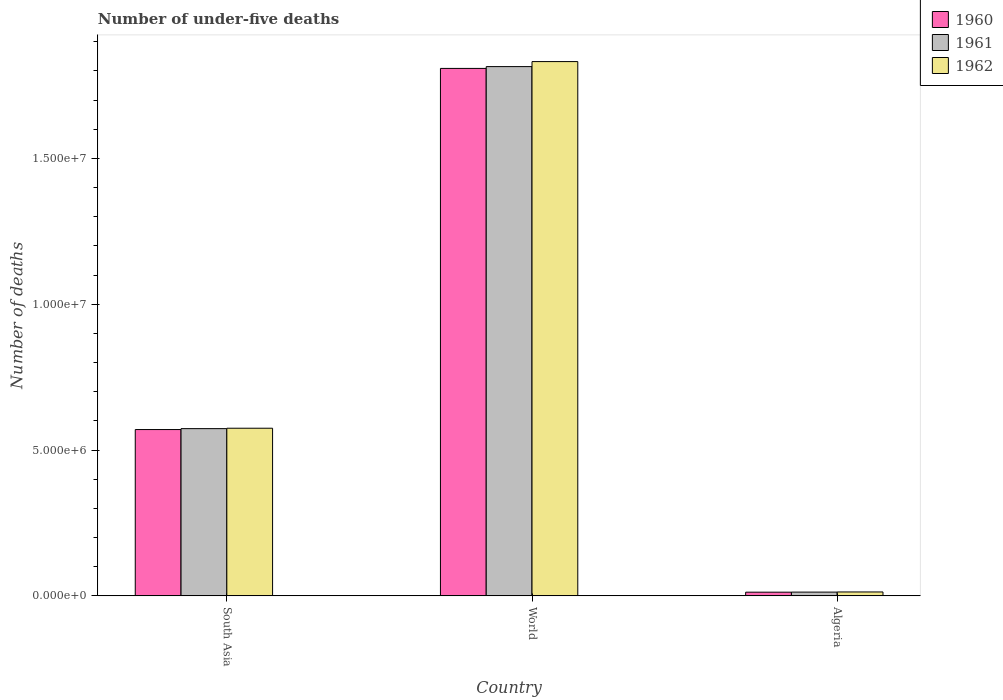How many different coloured bars are there?
Keep it short and to the point. 3. Are the number of bars per tick equal to the number of legend labels?
Provide a short and direct response. Yes. How many bars are there on the 2nd tick from the left?
Your answer should be compact. 3. How many bars are there on the 2nd tick from the right?
Ensure brevity in your answer.  3. In how many cases, is the number of bars for a given country not equal to the number of legend labels?
Provide a succinct answer. 0. What is the number of under-five deaths in 1960 in South Asia?
Ensure brevity in your answer.  5.70e+06. Across all countries, what is the maximum number of under-five deaths in 1960?
Offer a terse response. 1.81e+07. Across all countries, what is the minimum number of under-five deaths in 1962?
Offer a very short reply. 1.33e+05. In which country was the number of under-five deaths in 1960 minimum?
Give a very brief answer. Algeria. What is the total number of under-five deaths in 1960 in the graph?
Offer a terse response. 2.39e+07. What is the difference between the number of under-five deaths in 1962 in South Asia and that in World?
Provide a short and direct response. -1.26e+07. What is the difference between the number of under-five deaths in 1961 in Algeria and the number of under-five deaths in 1960 in South Asia?
Provide a succinct answer. -5.57e+06. What is the average number of under-five deaths in 1961 per country?
Give a very brief answer. 8.00e+06. What is the difference between the number of under-five deaths of/in 1962 and number of under-five deaths of/in 1960 in Algeria?
Your response must be concise. 7580. What is the ratio of the number of under-five deaths in 1961 in Algeria to that in South Asia?
Offer a very short reply. 0.02. What is the difference between the highest and the second highest number of under-five deaths in 1962?
Provide a short and direct response. -5.61e+06. What is the difference between the highest and the lowest number of under-five deaths in 1961?
Your answer should be compact. 1.80e+07. What does the 3rd bar from the left in World represents?
Ensure brevity in your answer.  1962. What does the 3rd bar from the right in World represents?
Provide a succinct answer. 1960. Is it the case that in every country, the sum of the number of under-five deaths in 1960 and number of under-five deaths in 1961 is greater than the number of under-five deaths in 1962?
Make the answer very short. Yes. How many bars are there?
Make the answer very short. 9. How many countries are there in the graph?
Your answer should be very brief. 3. Does the graph contain grids?
Your answer should be very brief. No. Where does the legend appear in the graph?
Offer a very short reply. Top right. How many legend labels are there?
Offer a very short reply. 3. What is the title of the graph?
Provide a succinct answer. Number of under-five deaths. Does "1985" appear as one of the legend labels in the graph?
Provide a short and direct response. No. What is the label or title of the Y-axis?
Keep it short and to the point. Number of deaths. What is the Number of deaths in 1960 in South Asia?
Your response must be concise. 5.70e+06. What is the Number of deaths of 1961 in South Asia?
Keep it short and to the point. 5.73e+06. What is the Number of deaths in 1962 in South Asia?
Make the answer very short. 5.75e+06. What is the Number of deaths in 1960 in World?
Your response must be concise. 1.81e+07. What is the Number of deaths of 1961 in World?
Provide a succinct answer. 1.81e+07. What is the Number of deaths in 1962 in World?
Provide a succinct answer. 1.83e+07. What is the Number of deaths of 1960 in Algeria?
Provide a short and direct response. 1.25e+05. What is the Number of deaths in 1961 in Algeria?
Ensure brevity in your answer.  1.28e+05. What is the Number of deaths in 1962 in Algeria?
Provide a short and direct response. 1.33e+05. Across all countries, what is the maximum Number of deaths in 1960?
Ensure brevity in your answer.  1.81e+07. Across all countries, what is the maximum Number of deaths of 1961?
Provide a short and direct response. 1.81e+07. Across all countries, what is the maximum Number of deaths of 1962?
Provide a short and direct response. 1.83e+07. Across all countries, what is the minimum Number of deaths in 1960?
Your answer should be compact. 1.25e+05. Across all countries, what is the minimum Number of deaths in 1961?
Provide a succinct answer. 1.28e+05. Across all countries, what is the minimum Number of deaths of 1962?
Offer a very short reply. 1.33e+05. What is the total Number of deaths in 1960 in the graph?
Provide a short and direct response. 2.39e+07. What is the total Number of deaths of 1961 in the graph?
Keep it short and to the point. 2.40e+07. What is the total Number of deaths of 1962 in the graph?
Give a very brief answer. 2.42e+07. What is the difference between the Number of deaths of 1960 in South Asia and that in World?
Your response must be concise. -1.24e+07. What is the difference between the Number of deaths of 1961 in South Asia and that in World?
Your answer should be very brief. -1.24e+07. What is the difference between the Number of deaths in 1962 in South Asia and that in World?
Provide a succinct answer. -1.26e+07. What is the difference between the Number of deaths in 1960 in South Asia and that in Algeria?
Your answer should be very brief. 5.58e+06. What is the difference between the Number of deaths in 1961 in South Asia and that in Algeria?
Make the answer very short. 5.60e+06. What is the difference between the Number of deaths of 1962 in South Asia and that in Algeria?
Make the answer very short. 5.61e+06. What is the difference between the Number of deaths of 1960 in World and that in Algeria?
Your answer should be compact. 1.80e+07. What is the difference between the Number of deaths of 1961 in World and that in Algeria?
Your answer should be very brief. 1.80e+07. What is the difference between the Number of deaths in 1962 in World and that in Algeria?
Your answer should be very brief. 1.82e+07. What is the difference between the Number of deaths of 1960 in South Asia and the Number of deaths of 1961 in World?
Offer a terse response. -1.24e+07. What is the difference between the Number of deaths in 1960 in South Asia and the Number of deaths in 1962 in World?
Ensure brevity in your answer.  -1.26e+07. What is the difference between the Number of deaths in 1961 in South Asia and the Number of deaths in 1962 in World?
Your answer should be very brief. -1.26e+07. What is the difference between the Number of deaths in 1960 in South Asia and the Number of deaths in 1961 in Algeria?
Give a very brief answer. 5.57e+06. What is the difference between the Number of deaths in 1960 in South Asia and the Number of deaths in 1962 in Algeria?
Give a very brief answer. 5.57e+06. What is the difference between the Number of deaths of 1961 in South Asia and the Number of deaths of 1962 in Algeria?
Provide a succinct answer. 5.60e+06. What is the difference between the Number of deaths in 1960 in World and the Number of deaths in 1961 in Algeria?
Ensure brevity in your answer.  1.80e+07. What is the difference between the Number of deaths in 1960 in World and the Number of deaths in 1962 in Algeria?
Keep it short and to the point. 1.80e+07. What is the difference between the Number of deaths of 1961 in World and the Number of deaths of 1962 in Algeria?
Your response must be concise. 1.80e+07. What is the average Number of deaths of 1960 per country?
Your answer should be compact. 7.97e+06. What is the average Number of deaths of 1961 per country?
Provide a short and direct response. 8.00e+06. What is the average Number of deaths of 1962 per country?
Provide a short and direct response. 8.07e+06. What is the difference between the Number of deaths in 1960 and Number of deaths in 1961 in South Asia?
Offer a terse response. -3.16e+04. What is the difference between the Number of deaths in 1960 and Number of deaths in 1962 in South Asia?
Keep it short and to the point. -4.54e+04. What is the difference between the Number of deaths of 1961 and Number of deaths of 1962 in South Asia?
Your answer should be compact. -1.37e+04. What is the difference between the Number of deaths of 1960 and Number of deaths of 1961 in World?
Your answer should be compact. -6.21e+04. What is the difference between the Number of deaths in 1960 and Number of deaths in 1962 in World?
Provide a succinct answer. -2.34e+05. What is the difference between the Number of deaths of 1961 and Number of deaths of 1962 in World?
Your answer should be very brief. -1.72e+05. What is the difference between the Number of deaths of 1960 and Number of deaths of 1961 in Algeria?
Offer a terse response. -2789. What is the difference between the Number of deaths of 1960 and Number of deaths of 1962 in Algeria?
Provide a succinct answer. -7580. What is the difference between the Number of deaths in 1961 and Number of deaths in 1962 in Algeria?
Offer a terse response. -4791. What is the ratio of the Number of deaths of 1960 in South Asia to that in World?
Your response must be concise. 0.32. What is the ratio of the Number of deaths in 1961 in South Asia to that in World?
Offer a terse response. 0.32. What is the ratio of the Number of deaths in 1962 in South Asia to that in World?
Make the answer very short. 0.31. What is the ratio of the Number of deaths in 1960 in South Asia to that in Algeria?
Give a very brief answer. 45.45. What is the ratio of the Number of deaths of 1961 in South Asia to that in Algeria?
Make the answer very short. 44.7. What is the ratio of the Number of deaths in 1962 in South Asia to that in Algeria?
Ensure brevity in your answer.  43.2. What is the ratio of the Number of deaths in 1960 in World to that in Algeria?
Offer a very short reply. 144.14. What is the ratio of the Number of deaths in 1961 in World to that in Algeria?
Offer a terse response. 141.49. What is the ratio of the Number of deaths of 1962 in World to that in Algeria?
Offer a terse response. 137.69. What is the difference between the highest and the second highest Number of deaths of 1960?
Keep it short and to the point. 1.24e+07. What is the difference between the highest and the second highest Number of deaths in 1961?
Offer a very short reply. 1.24e+07. What is the difference between the highest and the second highest Number of deaths in 1962?
Offer a very short reply. 1.26e+07. What is the difference between the highest and the lowest Number of deaths of 1960?
Your answer should be compact. 1.80e+07. What is the difference between the highest and the lowest Number of deaths of 1961?
Your answer should be very brief. 1.80e+07. What is the difference between the highest and the lowest Number of deaths of 1962?
Provide a short and direct response. 1.82e+07. 